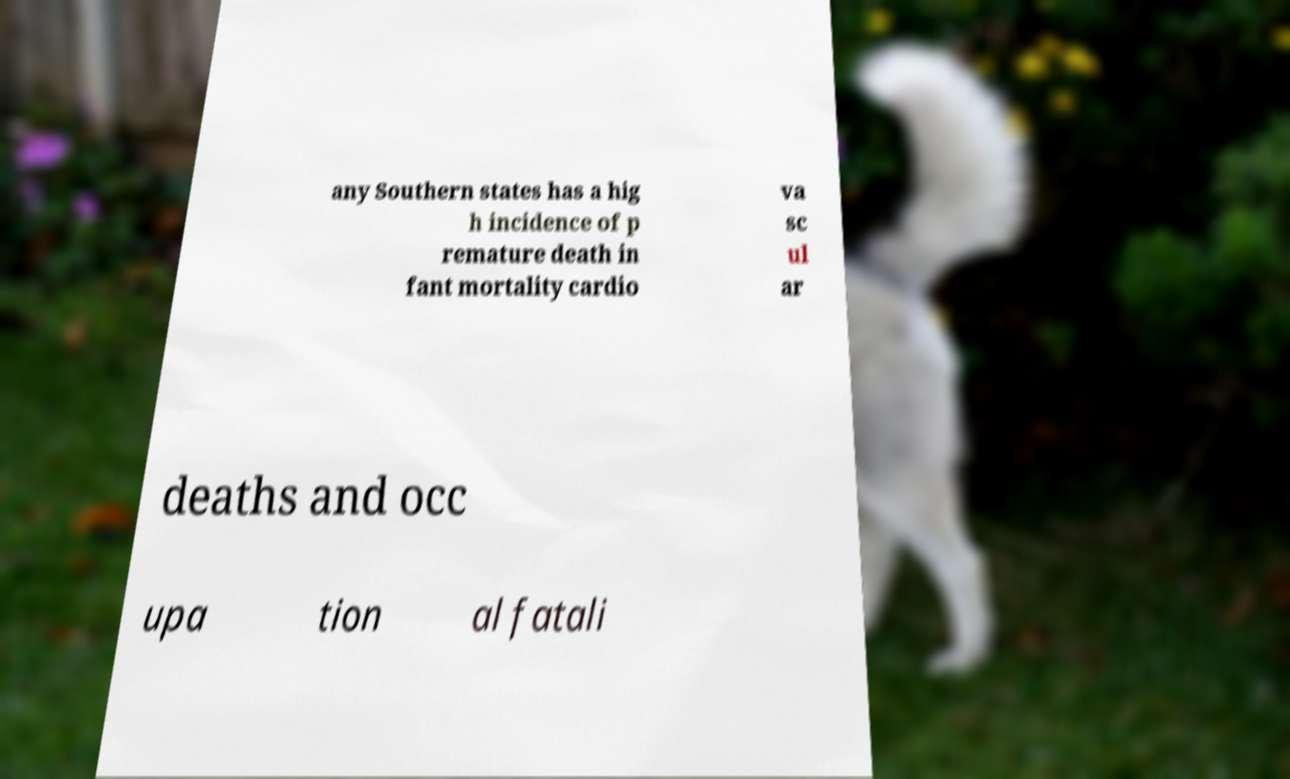Please identify and transcribe the text found in this image. any Southern states has a hig h incidence of p remature death in fant mortality cardio va sc ul ar deaths and occ upa tion al fatali 